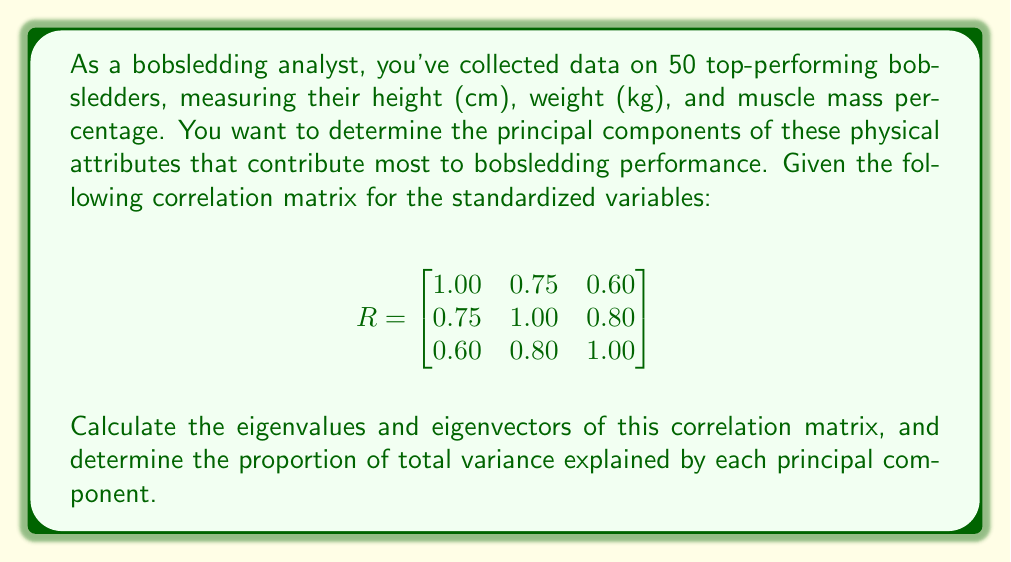Give your solution to this math problem. To solve this problem, we'll follow these steps:

1) Calculate the eigenvalues of the correlation matrix.
2) Calculate the eigenvectors corresponding to each eigenvalue.
3) Determine the proportion of variance explained by each principal component.

Step 1: Calculate the eigenvalues

To find the eigenvalues, we solve the characteristic equation:
$$ \det(R - \lambda I) = 0 $$

Expanding this determinant:

$$ \begin{vmatrix}
1-\lambda & 0.75 & 0.60 \\
0.75 & 1-\lambda & 0.80 \\
0.60 & 0.80 & 1-\lambda
\end{vmatrix} = 0 $$

$$(1-\lambda)^3 - 0.75^2(1-\lambda) - 0.60^2(1-\lambda) - 0.80^2(1-\lambda) + 2(0.75)(0.60)(0.80) = 0$$

Solving this equation (typically using computer software), we get:

$\lambda_1 \approx 2.4166$
$\lambda_2 \approx 0.4323$
$\lambda_3 \approx 0.1511$

Step 2: Calculate the eigenvectors

For each eigenvalue, we solve $(R - \lambda_i I)v_i = 0$ to find the corresponding eigenvector.

For $\lambda_1 \approx 2.4166$:
$$ v_1 \approx \begin{bmatrix} 0.5424 \\ 0.6088 \\ 0.5789 \end{bmatrix} $$

For $\lambda_2 \approx 0.4323$:
$$ v_2 \approx \begin{bmatrix} -0.7914 \\ 0.0033 \\ 0.6114 \end{bmatrix} $$

For $\lambda_3 \approx 0.1511$:
$$ v_3 \approx \begin{bmatrix} 0.2816 \\ -0.7933 \\ 0.5400 \end{bmatrix} $$

Step 3: Determine the proportion of variance explained

The total variance is the sum of the eigenvalues:
$$ \text{Total Variance} = 2.4166 + 0.4323 + 0.1511 = 3 $$

The proportion of variance explained by each principal component is:

PC1: $\frac{2.4166}{3} \approx 0.8055$ or 80.55%
PC2: $\frac{0.4323}{3} \approx 0.1441$ or 14.41%
PC3: $\frac{0.1511}{3} \approx 0.0504$ or 5.04%
Answer: The eigenvalues are approximately 2.4166, 0.4323, and 0.1511.

The corresponding eigenvectors are:
$$ v_1 \approx \begin{bmatrix} 0.5424 \\ 0.6088 \\ 0.5789 \end{bmatrix}, v_2 \approx \begin{bmatrix} -0.7914 \\ 0.0033 \\ 0.6114 \end{bmatrix}, v_3 \approx \begin{bmatrix} 0.2816 \\ -0.7933 \\ 0.5400 \end{bmatrix} $$

The proportion of total variance explained by each principal component is:
PC1: 80.55%, PC2: 14.41%, PC3: 5.04% 